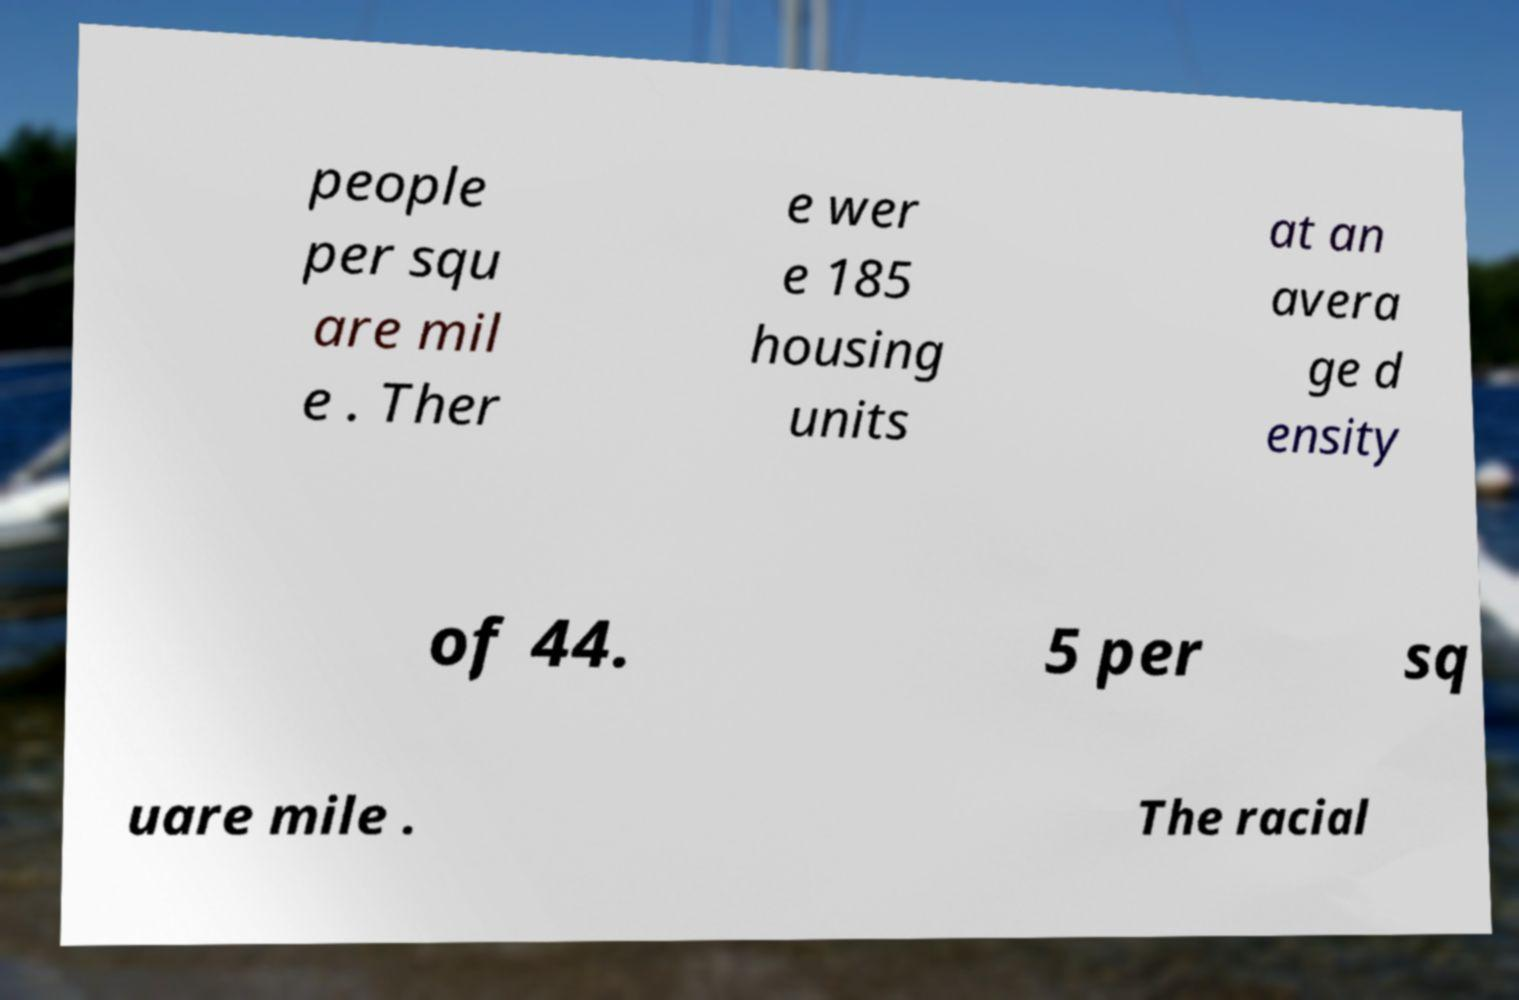Please read and relay the text visible in this image. What does it say? people per squ are mil e . Ther e wer e 185 housing units at an avera ge d ensity of 44. 5 per sq uare mile . The racial 